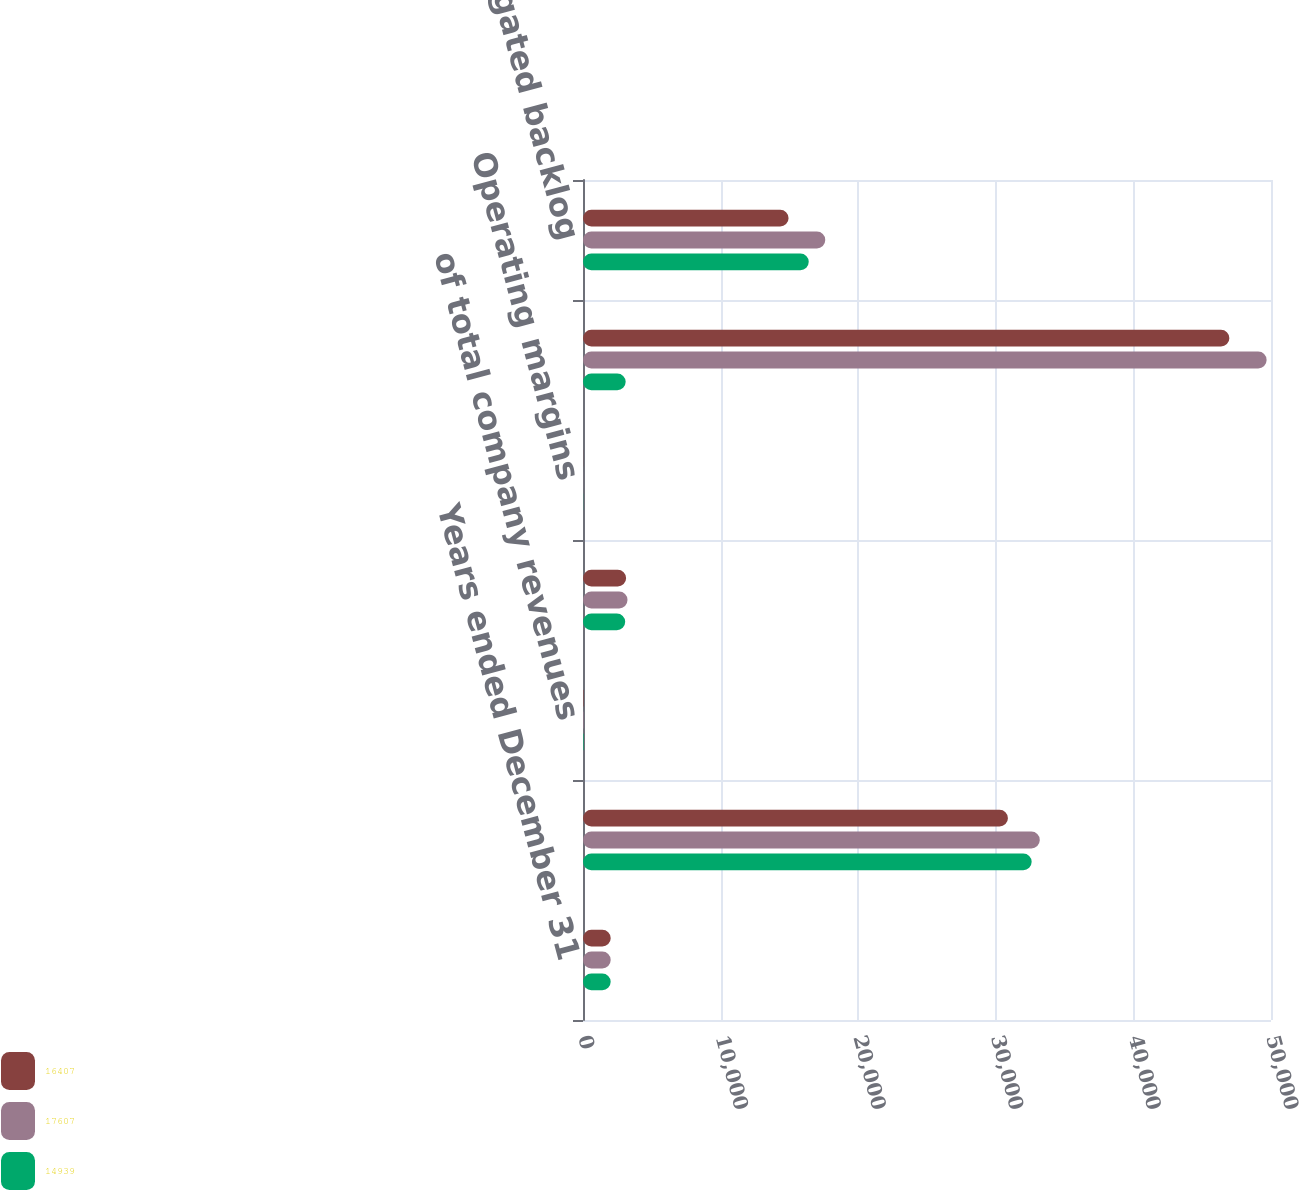Convert chart. <chart><loc_0><loc_0><loc_500><loc_500><stacked_bar_chart><ecel><fcel>Years ended December 31<fcel>Revenues<fcel>of total company revenues<fcel>Earnings from operations<fcel>Operating margins<fcel>Contractual backlog<fcel>Unobligated backlog<nl><fcel>16407<fcel>2014<fcel>30881<fcel>34<fcel>3133<fcel>10.1<fcel>46974<fcel>14939<nl><fcel>17607<fcel>2013<fcel>33197<fcel>38<fcel>3235<fcel>9.7<fcel>49681<fcel>17607<nl><fcel>14939<fcel>2012<fcel>32607<fcel>40<fcel>3068<fcel>9.4<fcel>3100.5<fcel>16407<nl></chart> 